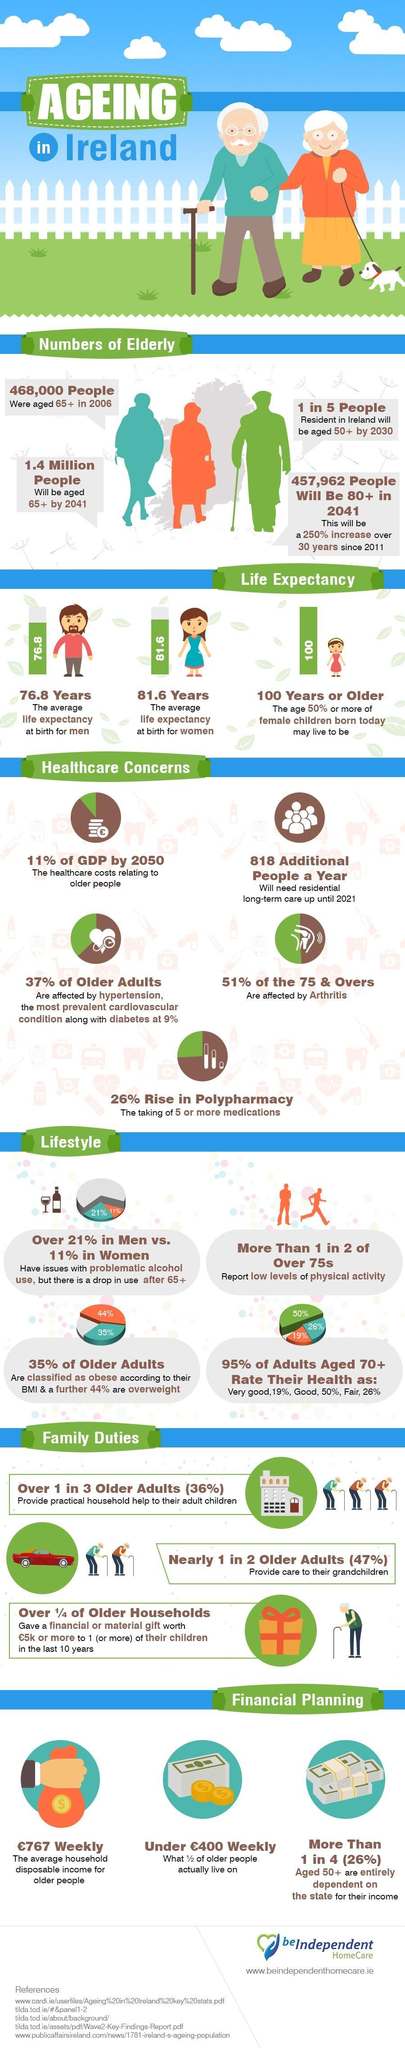What percentage of GDP will be contributed by the healthcare costs relating to the older people in Ireland by 2050?
Answer the question with a short phrase. 11% What percentage of older adults in Ireland are neither obese nor overweight? 21% What is the average life expectancy at birth for men in Ireland? 76.8 Years What is the average household disposable income for older people in Ireland? £767 Weekly What percentage of Irish people aged 75 & over are not affected by Arthritis? 49% What percent of Irish people aged 50+ depends entirely on the state of their income? (26%) What is the average life expectancy at birth for women in Ireland? 81.6 Years 